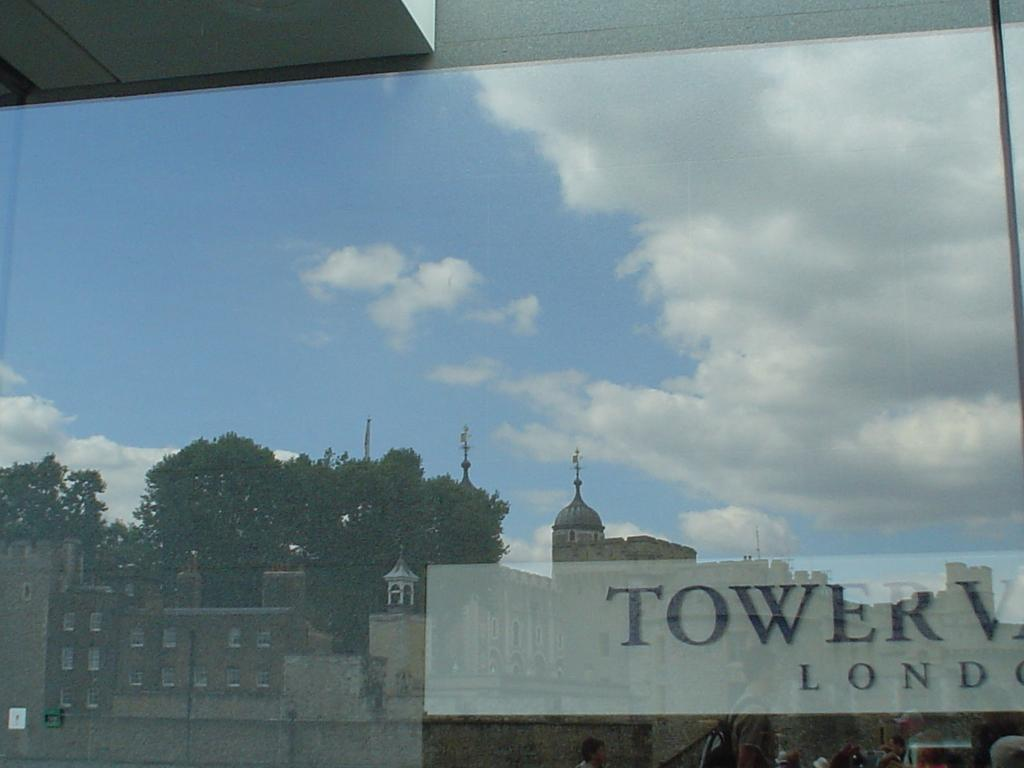<image>
Present a compact description of the photo's key features. The building across the way has the word "tower" written on it. 